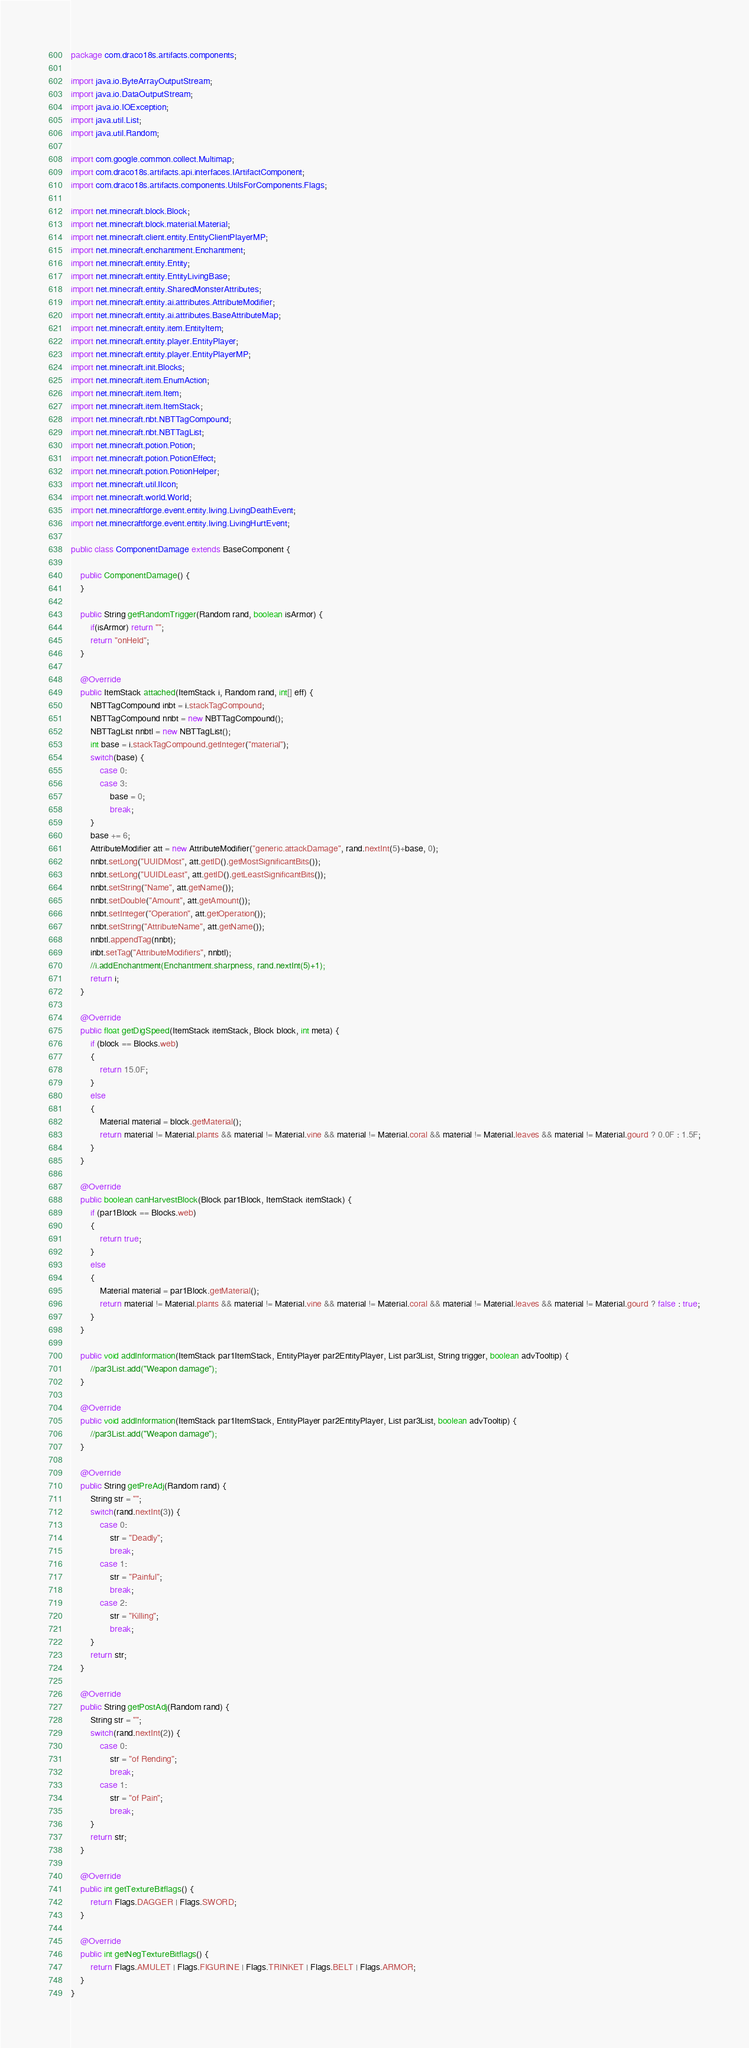<code> <loc_0><loc_0><loc_500><loc_500><_Java_>package com.draco18s.artifacts.components;

import java.io.ByteArrayOutputStream;
import java.io.DataOutputStream;
import java.io.IOException;
import java.util.List;
import java.util.Random;

import com.google.common.collect.Multimap;
import com.draco18s.artifacts.api.interfaces.IArtifactComponent;
import com.draco18s.artifacts.components.UtilsForComponents.Flags;

import net.minecraft.block.Block;
import net.minecraft.block.material.Material;
import net.minecraft.client.entity.EntityClientPlayerMP;
import net.minecraft.enchantment.Enchantment;
import net.minecraft.entity.Entity;
import net.minecraft.entity.EntityLivingBase;
import net.minecraft.entity.SharedMonsterAttributes;
import net.minecraft.entity.ai.attributes.AttributeModifier;
import net.minecraft.entity.ai.attributes.BaseAttributeMap;
import net.minecraft.entity.item.EntityItem;
import net.minecraft.entity.player.EntityPlayer;
import net.minecraft.entity.player.EntityPlayerMP;
import net.minecraft.init.Blocks;
import net.minecraft.item.EnumAction;
import net.minecraft.item.Item;
import net.minecraft.item.ItemStack;
import net.minecraft.nbt.NBTTagCompound;
import net.minecraft.nbt.NBTTagList;
import net.minecraft.potion.Potion;
import net.minecraft.potion.PotionEffect;
import net.minecraft.potion.PotionHelper;
import net.minecraft.util.IIcon;
import net.minecraft.world.World;
import net.minecraftforge.event.entity.living.LivingDeathEvent;
import net.minecraftforge.event.entity.living.LivingHurtEvent;

public class ComponentDamage extends BaseComponent {

	public ComponentDamage() {
	}
	
	public String getRandomTrigger(Random rand, boolean isArmor) {
		if(isArmor) return "";
		return "onHeld";
	}

	@Override
	public ItemStack attached(ItemStack i, Random rand, int[] eff) {
		NBTTagCompound inbt = i.stackTagCompound;
		NBTTagCompound nnbt = new NBTTagCompound();
		NBTTagList nnbtl = new NBTTagList();
		int base = i.stackTagCompound.getInteger("material");
		switch(base) {
			case 0:
			case 3:
				base = 0;
				break;
		}
		base += 6;
		AttributeModifier att = new AttributeModifier("generic.attackDamage", rand.nextInt(5)+base, 0);
		nnbt.setLong("UUIDMost", att.getID().getMostSignificantBits());
		nnbt.setLong("UUIDLeast", att.getID().getLeastSignificantBits());
		nnbt.setString("Name", att.getName());
		nnbt.setDouble("Amount", att.getAmount());
		nnbt.setInteger("Operation", att.getOperation());
		nnbt.setString("AttributeName", att.getName());
		nnbtl.appendTag(nnbt);
		inbt.setTag("AttributeModifiers", nnbtl);
		//i.addEnchantment(Enchantment.sharpness, rand.nextInt(5)+1);
		return i;
	}

	@Override
	public float getDigSpeed(ItemStack itemStack, Block block, int meta) {
		if (block == Blocks.web)
        {
            return 15.0F;
        }
        else
        {
            Material material = block.getMaterial();
            return material != Material.plants && material != Material.vine && material != Material.coral && material != Material.leaves && material != Material.gourd ? 0.0F : 1.5F;
        }
	}

	@Override
	public boolean canHarvestBlock(Block par1Block, ItemStack itemStack) {
		if (par1Block == Blocks.web)
        {
            return true;
        }
        else
        {
            Material material = par1Block.getMaterial();
            return material != Material.plants && material != Material.vine && material != Material.coral && material != Material.leaves && material != Material.gourd ? false : true;
        }
	}

	public void addInformation(ItemStack par1ItemStack, EntityPlayer par2EntityPlayer, List par3List, String trigger, boolean advTooltip) {
		//par3List.add("Weapon damage");
	}

	@Override
	public void addInformation(ItemStack par1ItemStack, EntityPlayer par2EntityPlayer, List par3List, boolean advTooltip) {
		//par3List.add("Weapon damage");
	}

	@Override
	public String getPreAdj(Random rand) {
		String str = "";
		switch(rand.nextInt(3)) {
			case 0:
				str = "Deadly";
				break;
			case 1:
				str = "Painful";
				break;
			case 2:
				str = "Killing";
				break;
		}
		return str;
	}

	@Override
	public String getPostAdj(Random rand) {
		String str = "";
		switch(rand.nextInt(2)) {
			case 0:
				str = "of Rending";
				break;
			case 1:
				str = "of Pain";
				break;
		}
		return str;
	}

	@Override
	public int getTextureBitflags() {
		return Flags.DAGGER | Flags.SWORD;
	}

	@Override
	public int getNegTextureBitflags() {
		return Flags.AMULET | Flags.FIGURINE | Flags.TRINKET | Flags.BELT | Flags.ARMOR;
	}
}
</code> 